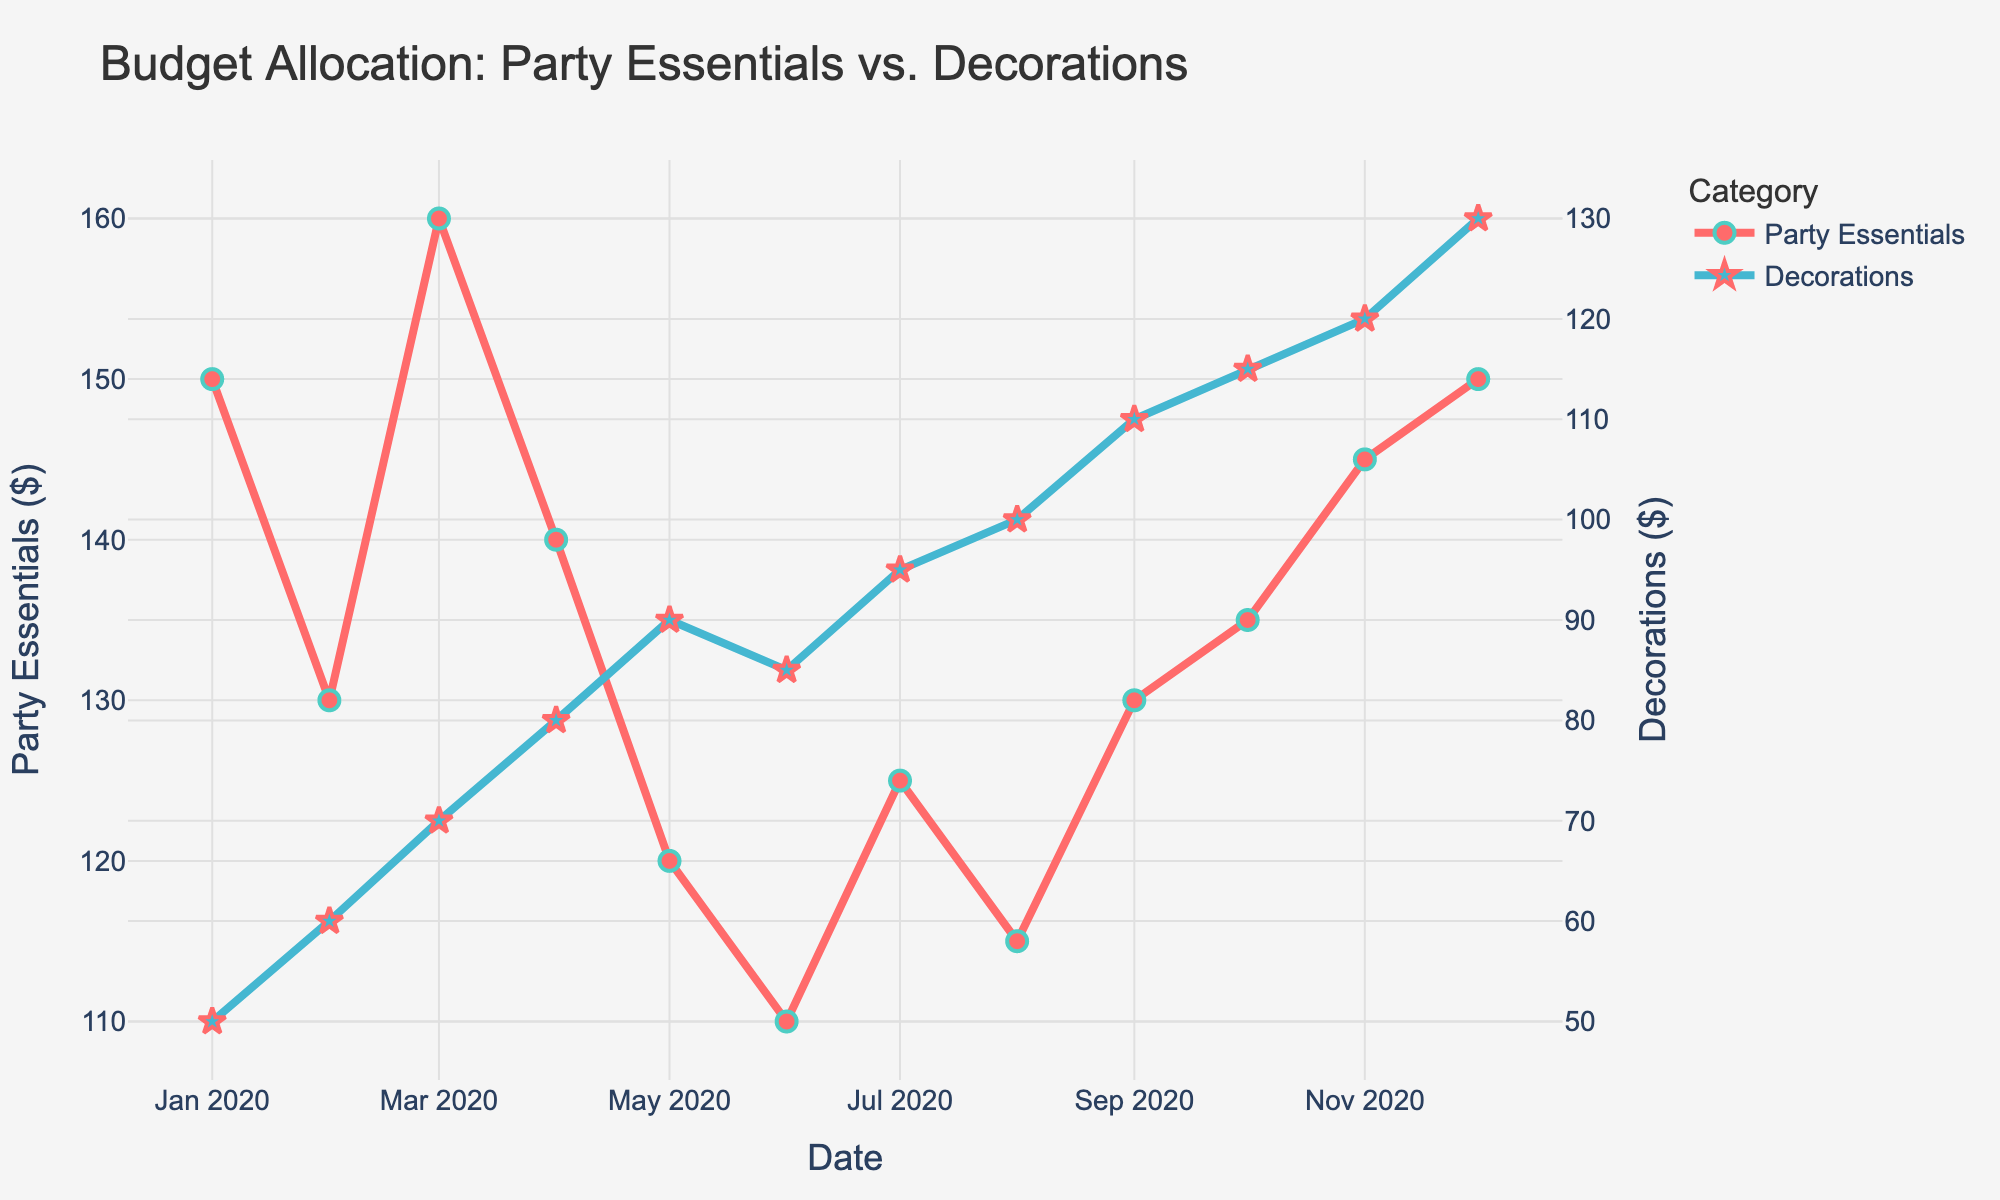What is the title of the figure? The title of the figure is located at the top center and generally summarizes the main subject of the plot. In this case, it explicitly mentions the budget allocation for two categories over time.
Answer: Budget Allocation: Party Essentials vs. Decorations What does the x-axis represent? The x-axis, labeled at the bottom of the plot, displays the timeline over which the data has been recorded. The dates range from January 2020 to December 2020.
Answer: Date What color represents the Party Essentials budget? In the plot, the Party Essentials budget is represented by lines and markers of a specific color. This color is mentioned in the code provided.
Answer: Red How does the budget for Decorations change from January to December 2020? To observe the change in the Decorations budget, one can trace the blue line across the months from January to December. The budget steadily increases from $50 to $130.
Answer: It increases When is the highest budget allocation for Decorations recorded? By looking at the peak values on the right axis which corresponds to the Decorations and observing the plotted points, you can identify the month where the value is highest. This occurs in December 2020 with a value of $130.
Answer: December 2020 What is the difference in budget allocation between Party Essentials and Decorations in June 2020? To find the difference, locate the values for both categories in June 2020 and subtract the smaller value from the larger one. Party Essentials is $110 and Decorations is $85, so \(110 - 85 = 25\).
Answer: $25 How many data points are there for each category? By counting the number of plotted points or noting the number of date entries on the x-axis, you can determine that both categories share the same data points spanning 12 months.
Answer: 12 During which month was the budget allocation for Party Essentials the lowest? Identify the lowest plotted point for Party Essentials within the plotted graph. The budget is lowest in June 2020 with a value of $110.
Answer: June 2020 Which category had a more consistent budget allocation throughout the year? Consistency can be determined by analyzing the smoothness and variance of the plotted lines. The Party Essentials budget fluctuates but remains more steady compared to the sharper increase in the Decorations budget.
Answer: Party Essentials What's the average budget allocation for Decorations in the first half of the year? To find the average, sum the values from January to June for Decorations and divide by 6. \((50+60+70+80+90+85)/6 = 72.5\).
Answer: $72.5 